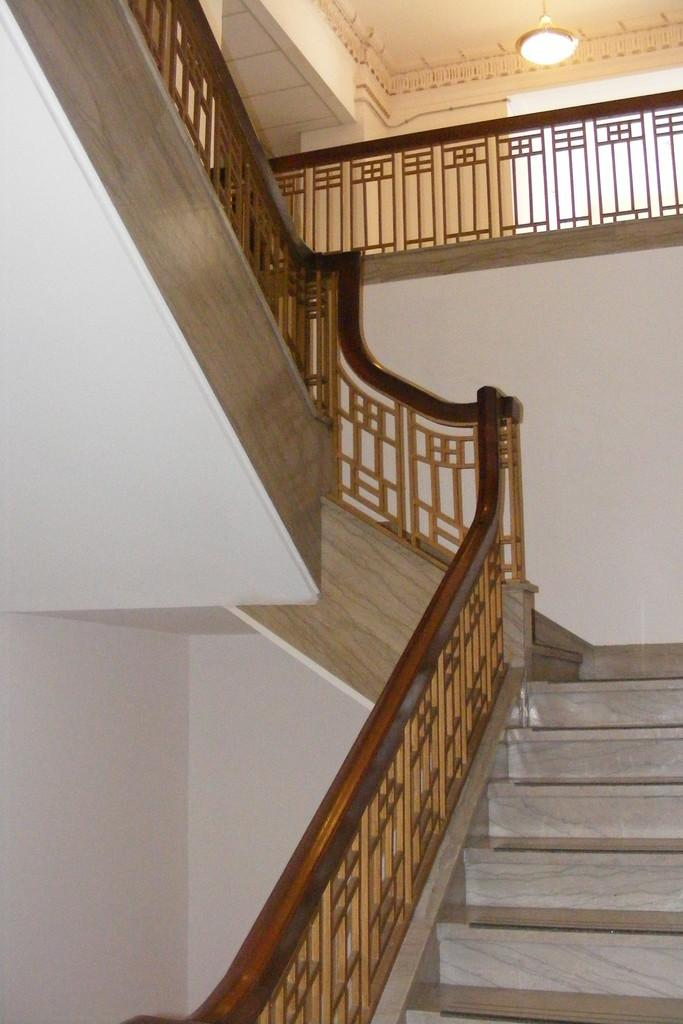What type of structure is present in the image? There is a staircase with railings in the image. Can you describe the railings in the image? There is a railing in the back of the image, and there are also railings on the staircase. What is the source of light in the image? There is a light on the ceiling in the image. What is located on the right side of the image? There is a wall on the right side of the image. Can you describe the snake that is hiding under the staircase in the image? There is no snake present in the image; it only features a staircase with railings, a railing in the back, a light on the ceiling, and a wall on the right side. 